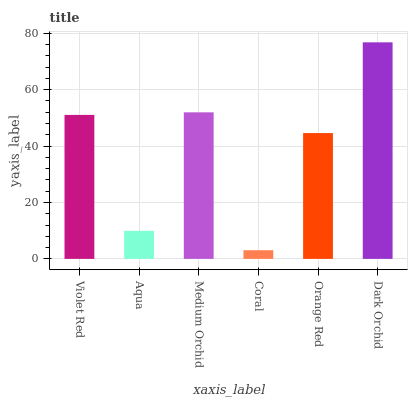Is Coral the minimum?
Answer yes or no. Yes. Is Dark Orchid the maximum?
Answer yes or no. Yes. Is Aqua the minimum?
Answer yes or no. No. Is Aqua the maximum?
Answer yes or no. No. Is Violet Red greater than Aqua?
Answer yes or no. Yes. Is Aqua less than Violet Red?
Answer yes or no. Yes. Is Aqua greater than Violet Red?
Answer yes or no. No. Is Violet Red less than Aqua?
Answer yes or no. No. Is Violet Red the high median?
Answer yes or no. Yes. Is Orange Red the low median?
Answer yes or no. Yes. Is Orange Red the high median?
Answer yes or no. No. Is Aqua the low median?
Answer yes or no. No. 